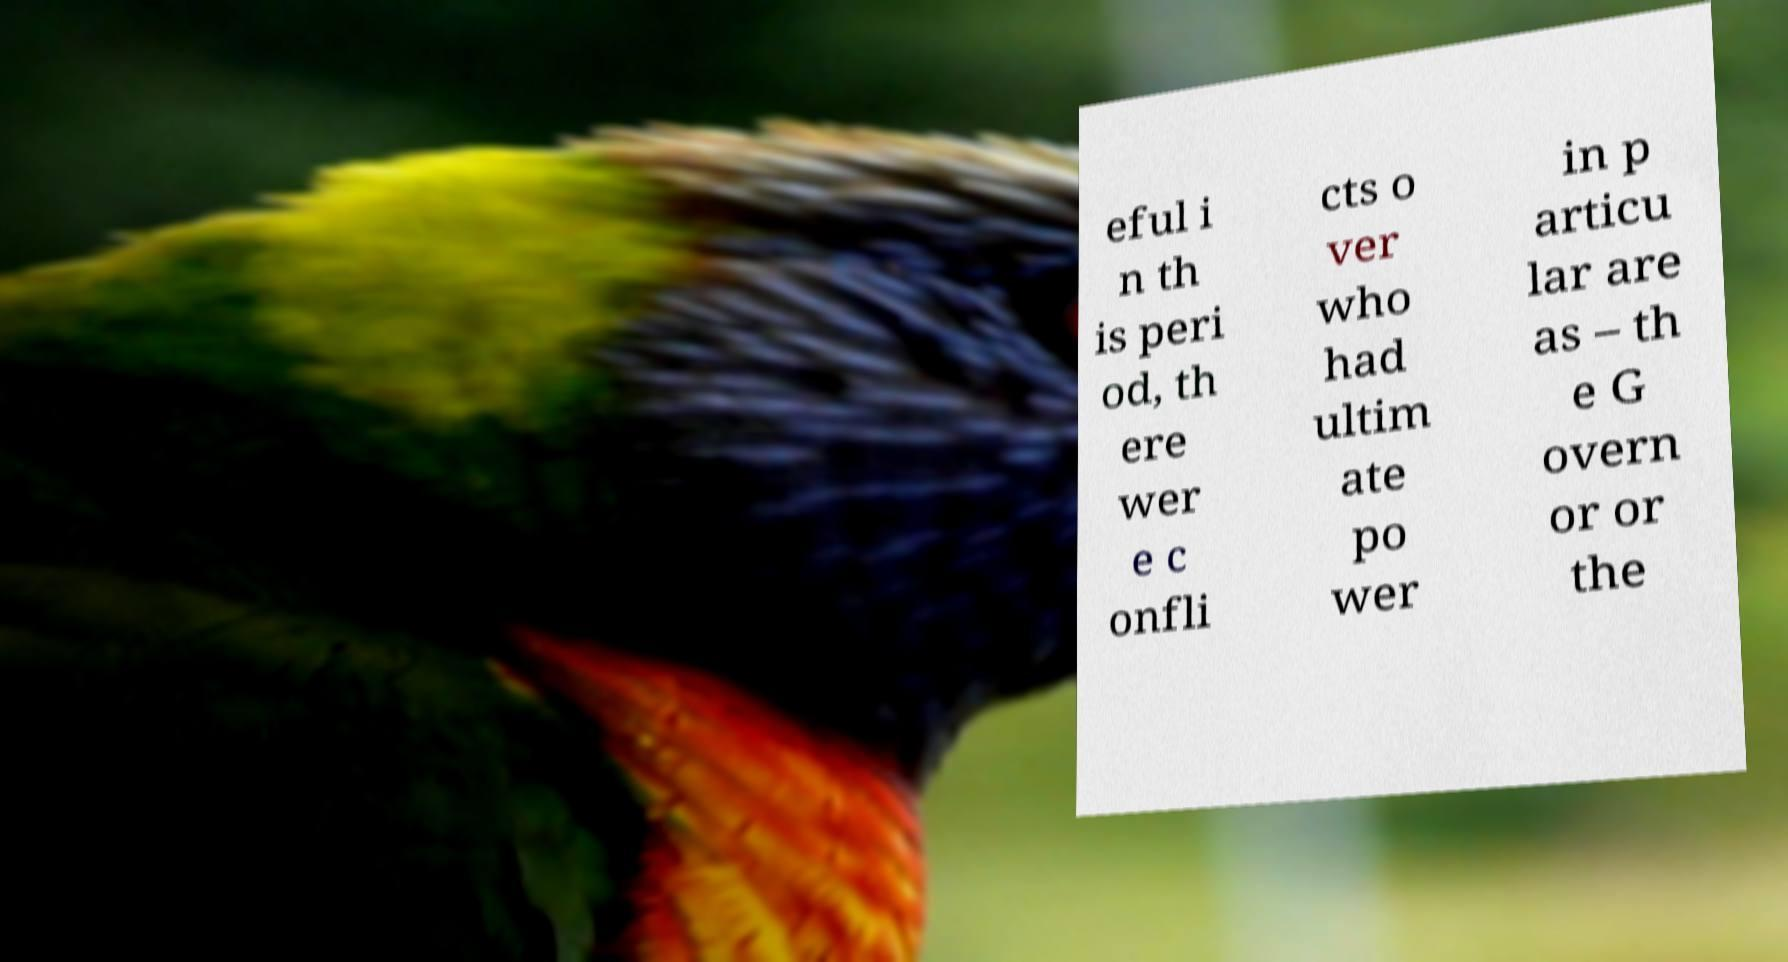What messages or text are displayed in this image? I need them in a readable, typed format. eful i n th is peri od, th ere wer e c onfli cts o ver who had ultim ate po wer in p articu lar are as – th e G overn or or the 